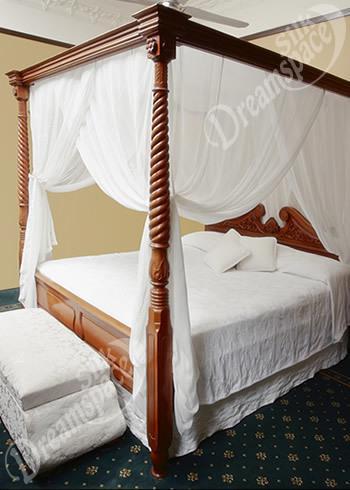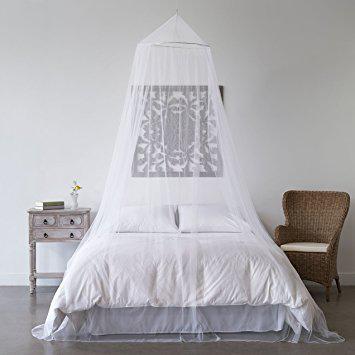The first image is the image on the left, the second image is the image on the right. Evaluate the accuracy of this statement regarding the images: "The bed on the right is draped by a canopy that descends from a centrally suspended cone shape.". Is it true? Answer yes or no. Yes. 